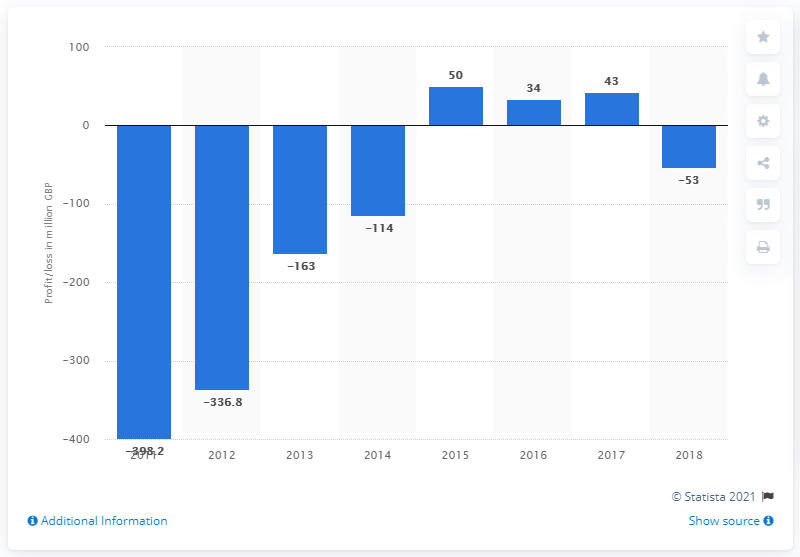Highlight a few significant elements in this photo. Thomas Cook's pre-tax profit in 2015 was approximately 50 million. 